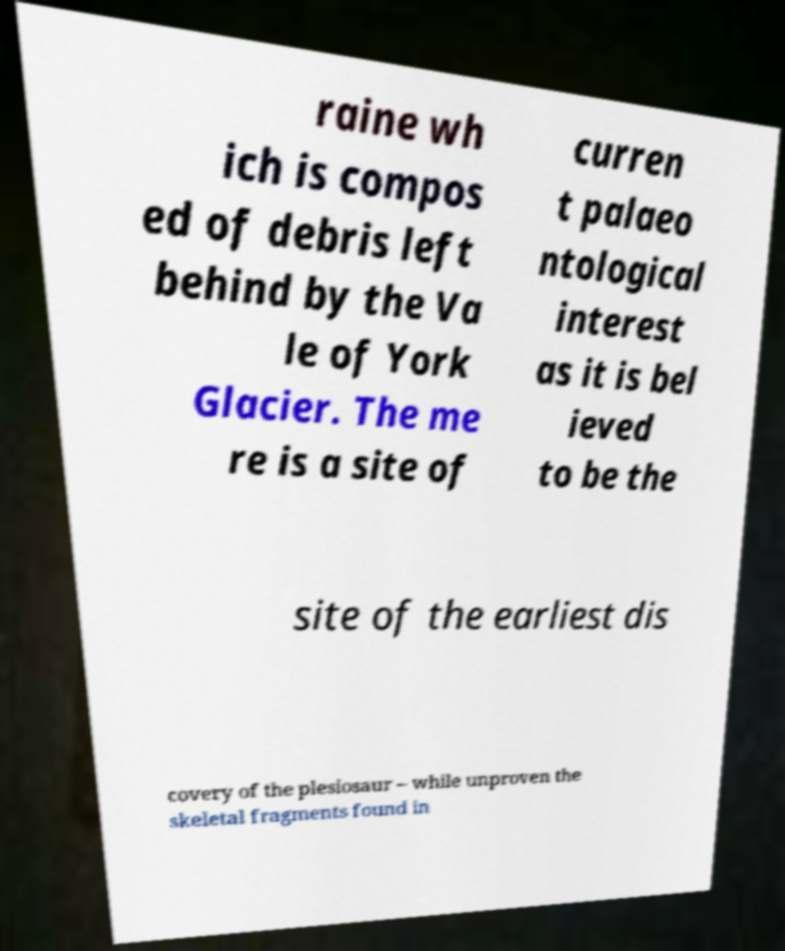Can you read and provide the text displayed in the image?This photo seems to have some interesting text. Can you extract and type it out for me? raine wh ich is compos ed of debris left behind by the Va le of York Glacier. The me re is a site of curren t palaeo ntological interest as it is bel ieved to be the site of the earliest dis covery of the plesiosaur – while unproven the skeletal fragments found in 